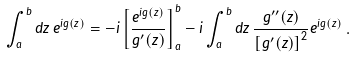Convert formula to latex. <formula><loc_0><loc_0><loc_500><loc_500>\int _ { a } ^ { b } d z \, e ^ { i g ( z ) } = - i \left [ \frac { e ^ { i g ( z ) } } { g ^ { \prime } ( z ) } \right ] _ { a } ^ { b } - i \int _ { a } ^ { b } d z \, \frac { g ^ { \prime \prime } ( z ) } { \left [ g ^ { \prime } ( z ) \right ] ^ { 2 } } e ^ { i g ( z ) } \, .</formula> 